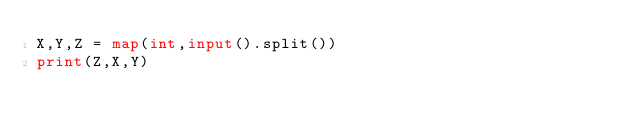Convert code to text. <code><loc_0><loc_0><loc_500><loc_500><_Python_>X,Y,Z = map(int,input().split())
print(Z,X,Y)</code> 